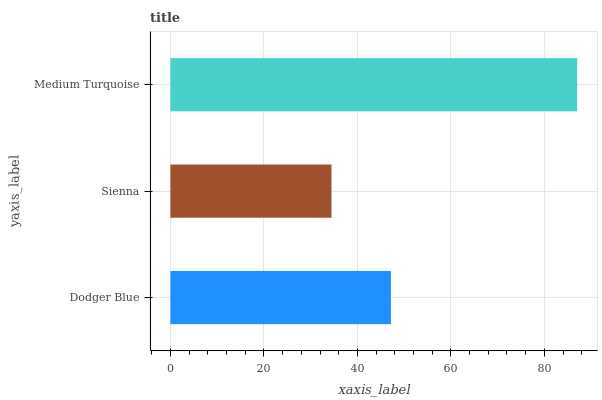Is Sienna the minimum?
Answer yes or no. Yes. Is Medium Turquoise the maximum?
Answer yes or no. Yes. Is Medium Turquoise the minimum?
Answer yes or no. No. Is Sienna the maximum?
Answer yes or no. No. Is Medium Turquoise greater than Sienna?
Answer yes or no. Yes. Is Sienna less than Medium Turquoise?
Answer yes or no. Yes. Is Sienna greater than Medium Turquoise?
Answer yes or no. No. Is Medium Turquoise less than Sienna?
Answer yes or no. No. Is Dodger Blue the high median?
Answer yes or no. Yes. Is Dodger Blue the low median?
Answer yes or no. Yes. Is Sienna the high median?
Answer yes or no. No. Is Sienna the low median?
Answer yes or no. No. 